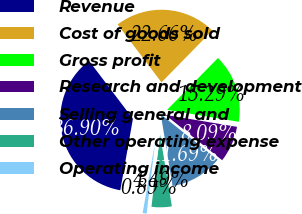Convert chart. <chart><loc_0><loc_0><loc_500><loc_500><pie_chart><fcel>Revenue<fcel>Cost of goods sold<fcel>Gross profit<fcel>Research and development<fcel>Selling general and<fcel>Other operating expense<fcel>Operating income<nl><fcel>36.9%<fcel>22.66%<fcel>15.29%<fcel>8.09%<fcel>11.69%<fcel>4.49%<fcel>0.89%<nl></chart> 